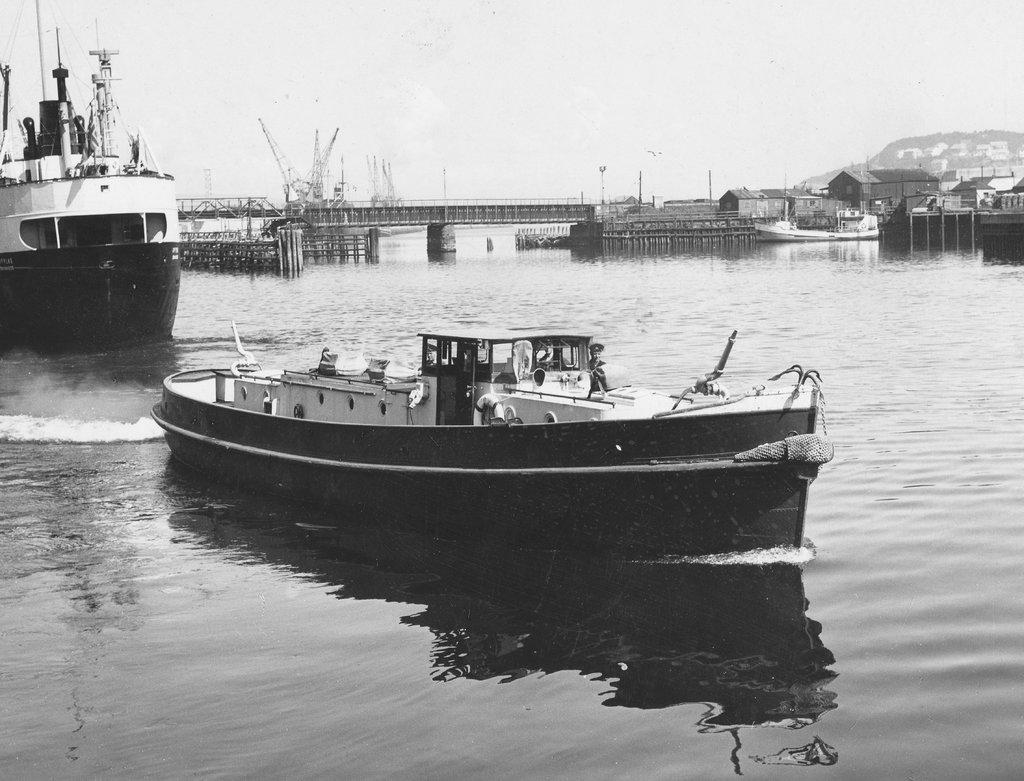What is in the water in the image? There are ships in the water in the image. What is the color scheme of the image? The image is black and white in color. What can be seen in the background of the image? There are houses, poles, and other unspecified objects in the background. How many children are attempting to climb the poles in the image? There are no people, let alone children, attempting to climb the poles in the image. The image only shows ships in the water, and the poles are in the background without any people near them. 